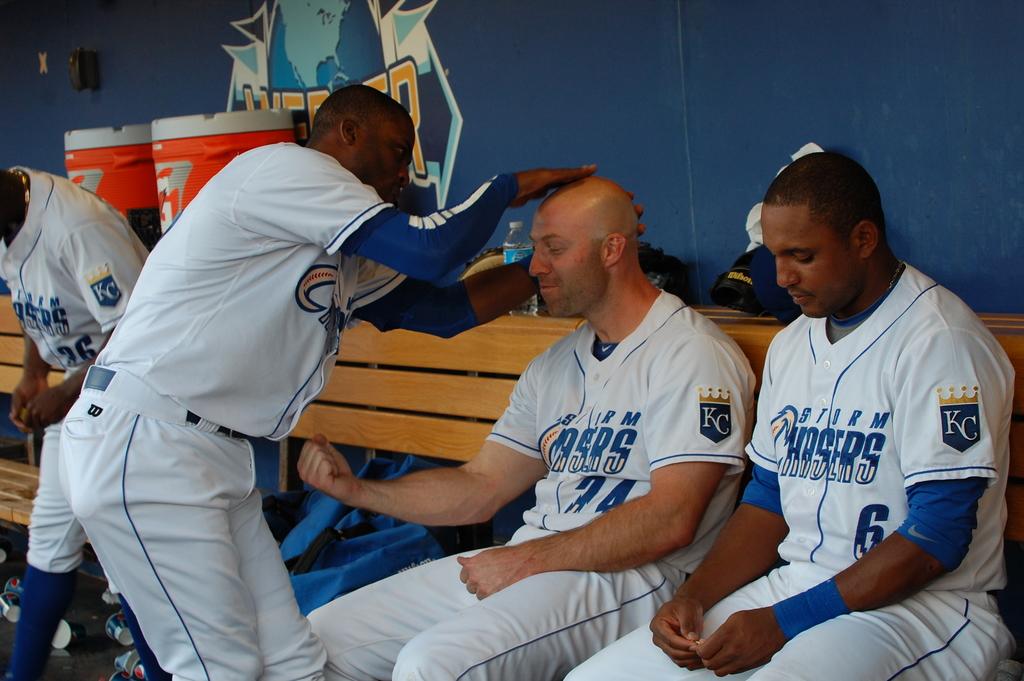What is the jersey number of the man on the right?
Your response must be concise. 6. 